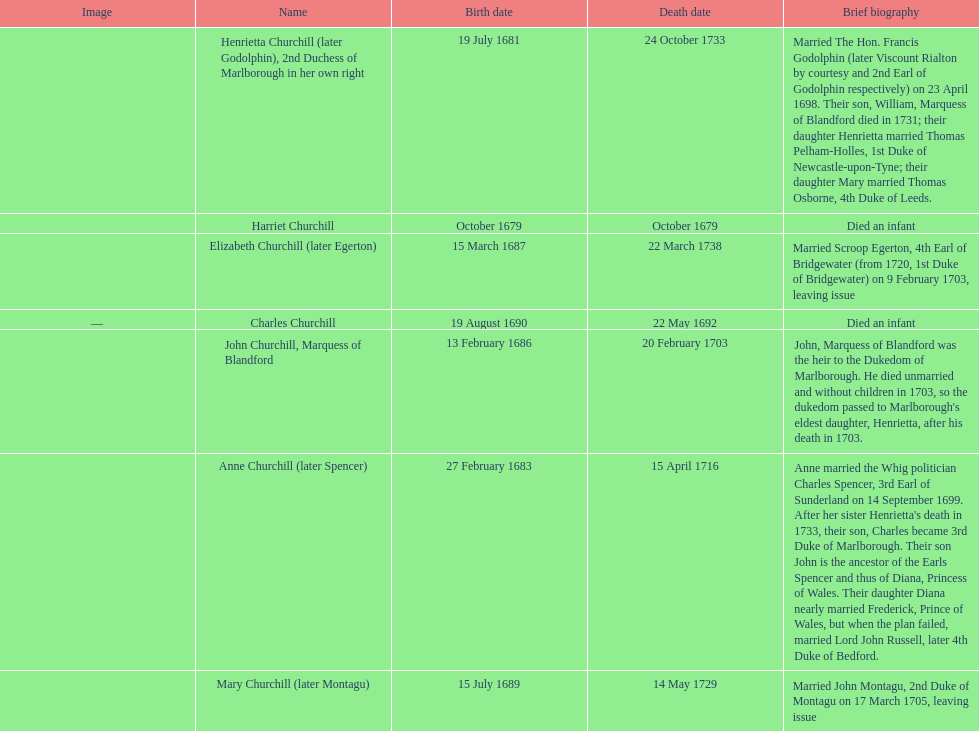What is the total number of children born after 1675? 7. 